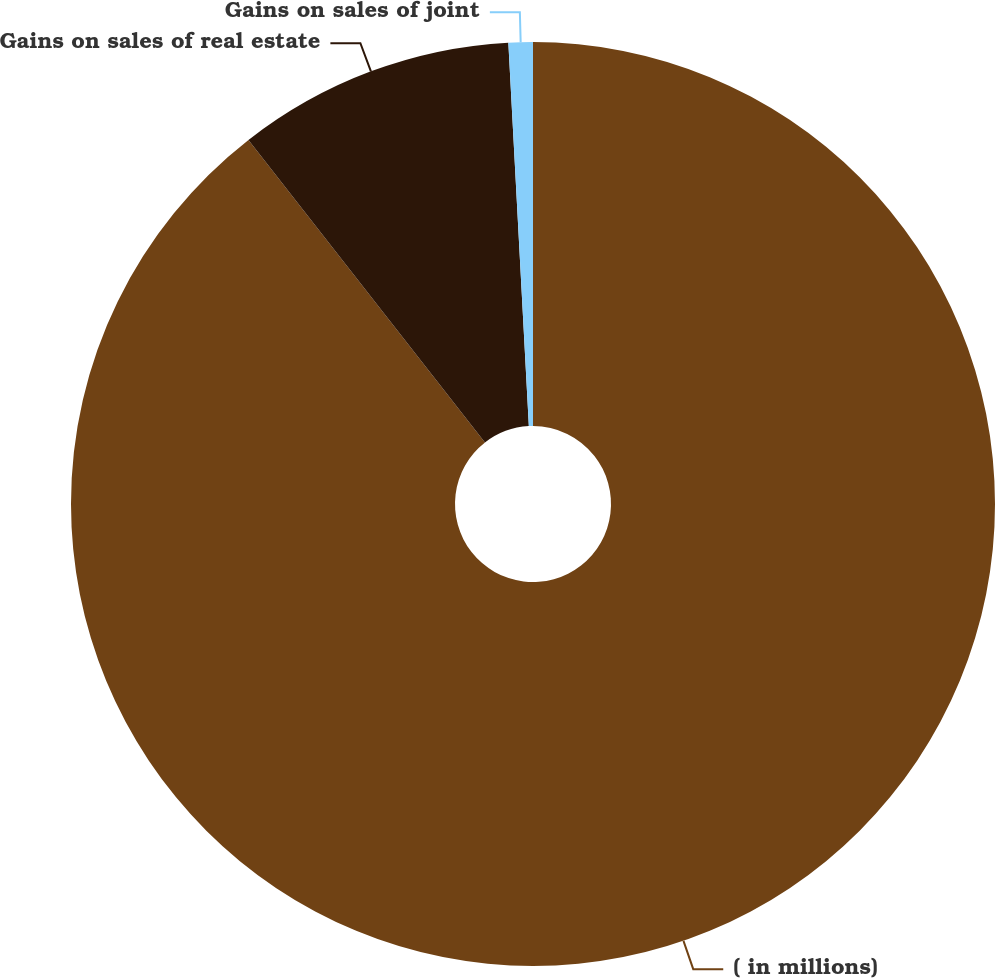Convert chart to OTSL. <chart><loc_0><loc_0><loc_500><loc_500><pie_chart><fcel>( in millions)<fcel>Gains on sales of real estate<fcel>Gains on sales of joint<nl><fcel>89.44%<fcel>9.71%<fcel>0.85%<nl></chart> 